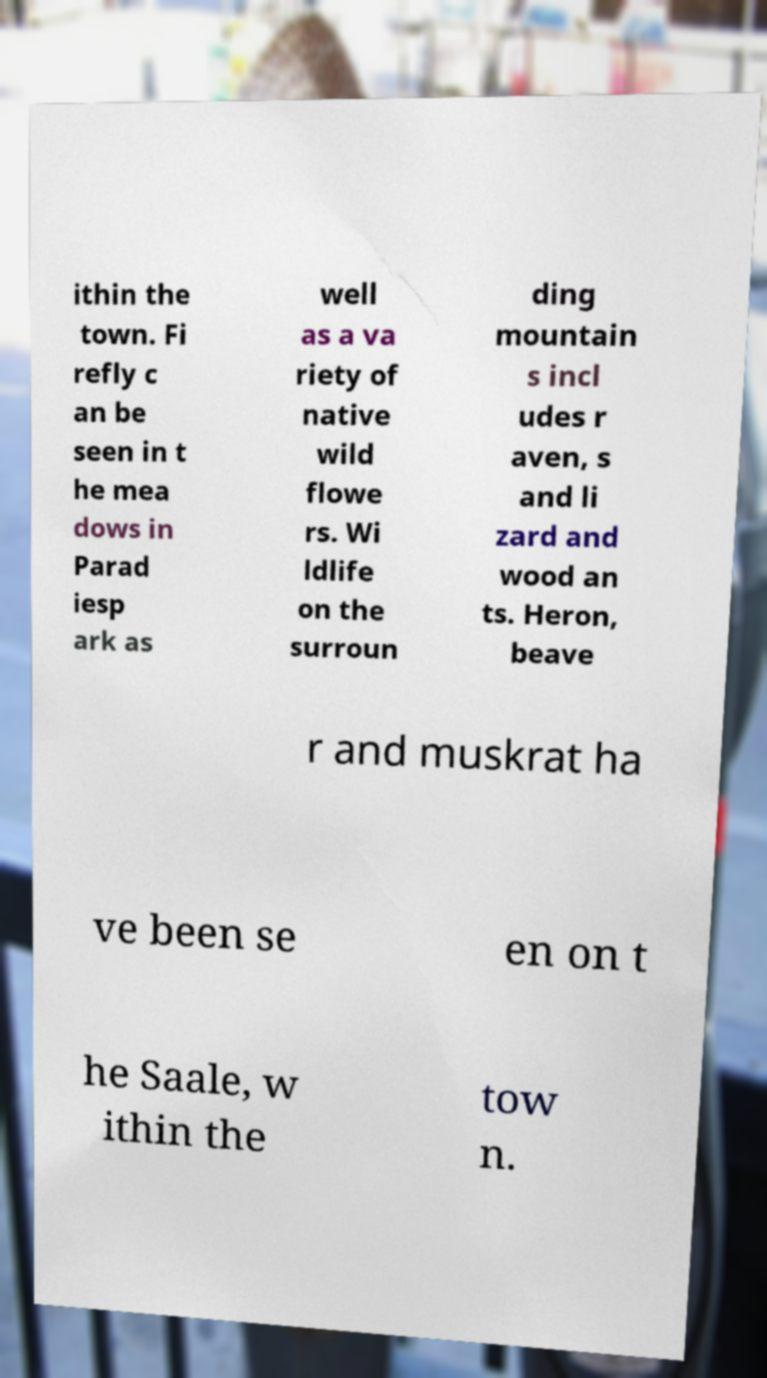Please identify and transcribe the text found in this image. ithin the town. Fi refly c an be seen in t he mea dows in Parad iesp ark as well as a va riety of native wild flowe rs. Wi ldlife on the surroun ding mountain s incl udes r aven, s and li zard and wood an ts. Heron, beave r and muskrat ha ve been se en on t he Saale, w ithin the tow n. 